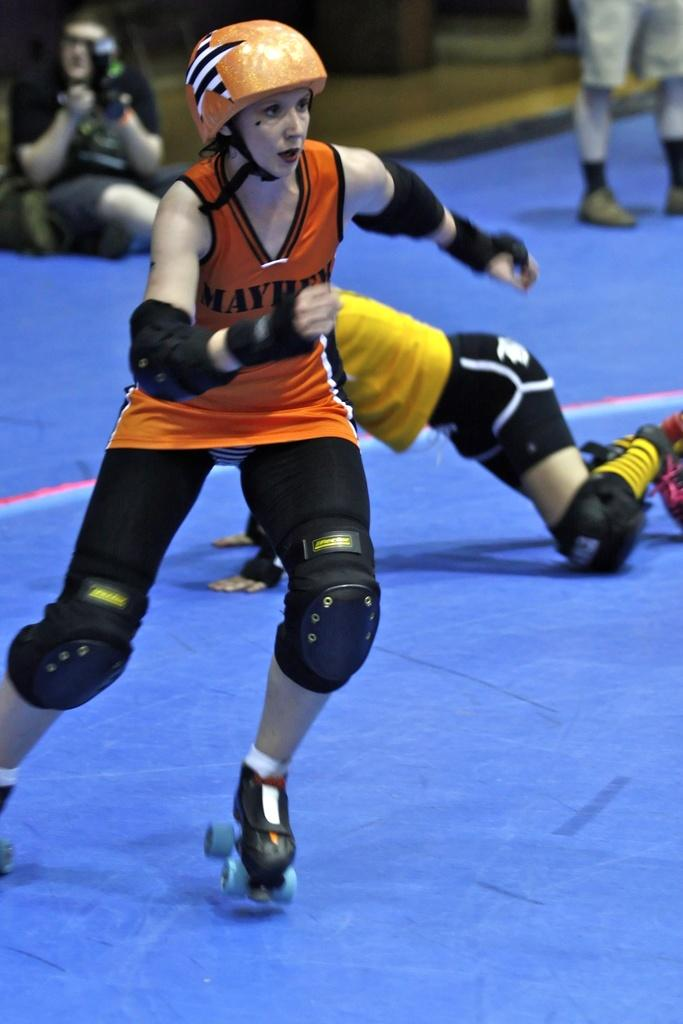What is the primary subject of the image? There is a person standing on the ground in the image. Can you describe the surroundings of the person? There are other persons visible in the background of the image. What type of wrench is the person using to act in the image? There is no wrench present in the image, and the person is not performing any actions that would require a wrench. 